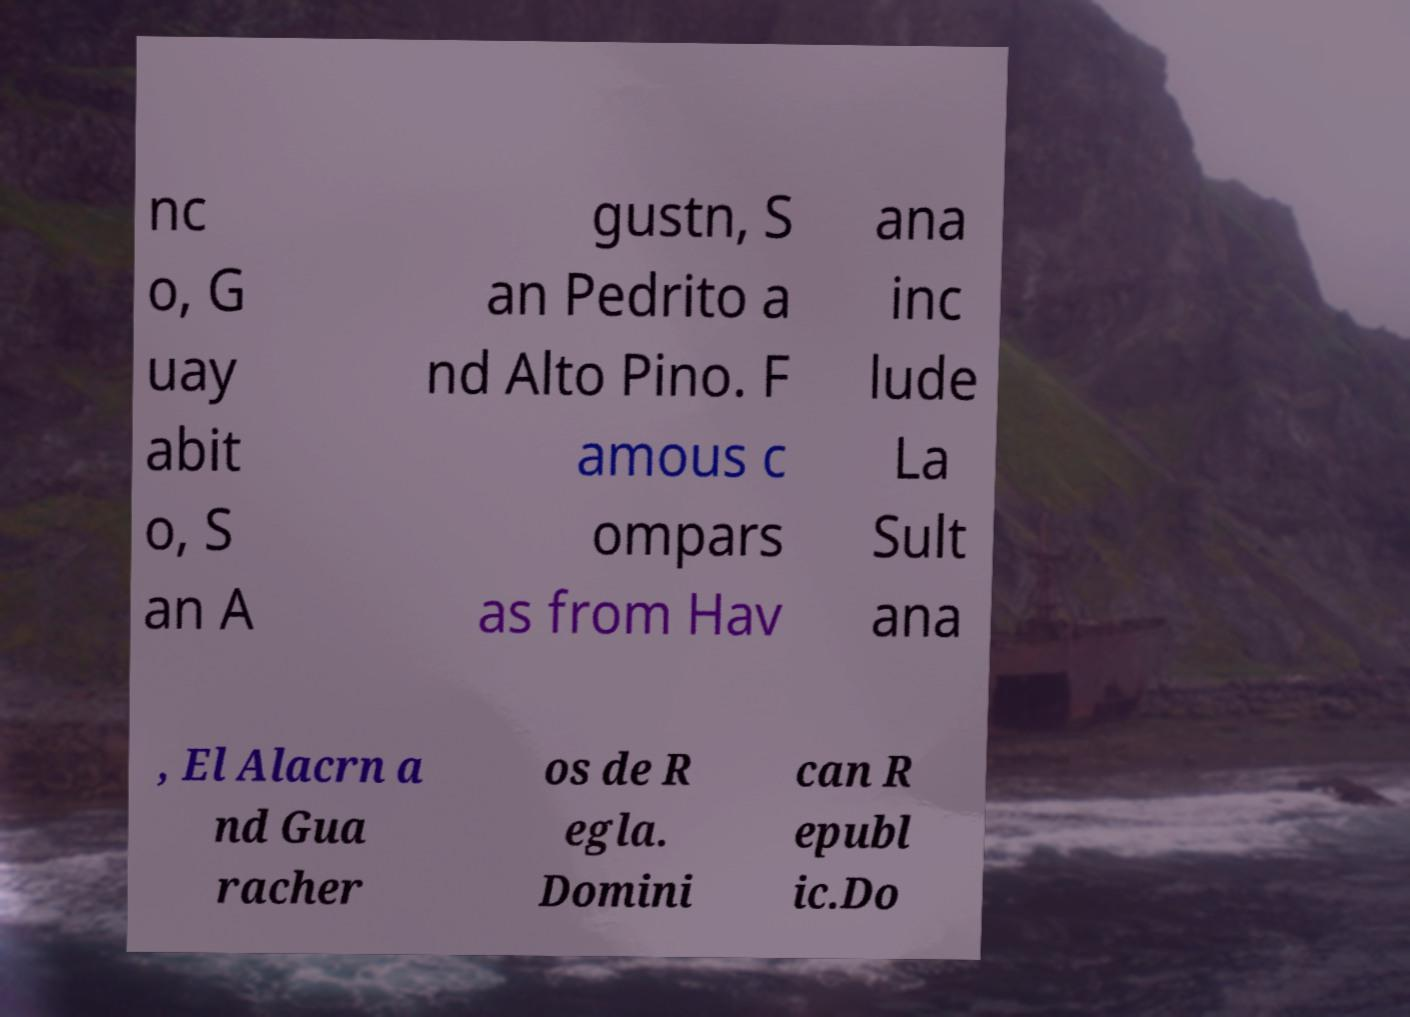Please read and relay the text visible in this image. What does it say? nc o, G uay abit o, S an A gustn, S an Pedrito a nd Alto Pino. F amous c ompars as from Hav ana inc lude La Sult ana , El Alacrn a nd Gua racher os de R egla. Domini can R epubl ic.Do 